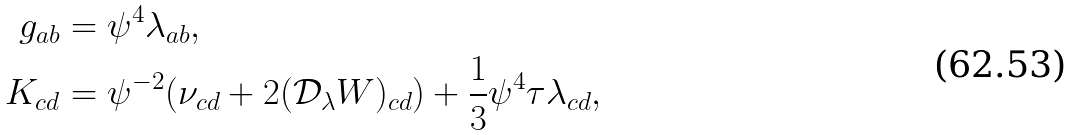<formula> <loc_0><loc_0><loc_500><loc_500>g _ { a b } & = \psi ^ { 4 } \lambda _ { a b } , \\ K _ { c d } & = \psi ^ { - 2 } ( \nu _ { c d } + 2 ( \mathcal { D } _ { \lambda } W ) _ { c d } ) + \frac { 1 } { 3 } \psi ^ { 4 } \tau \lambda _ { c d } ,</formula> 